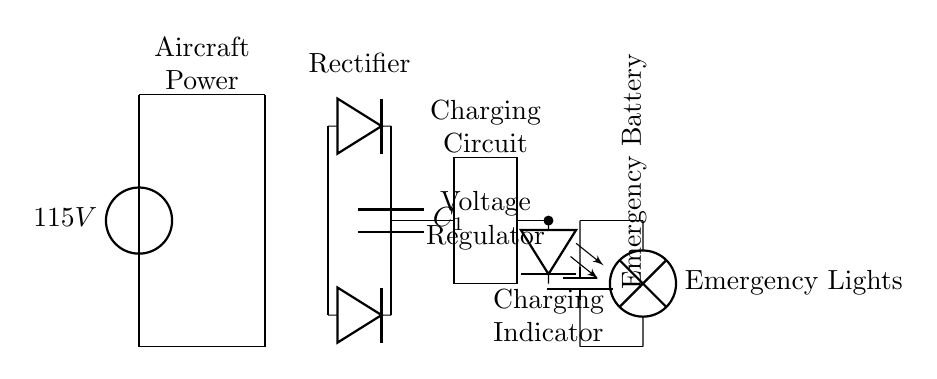What is the primary voltage source for the circuit? The circuit is powered by a primary voltage source of 115V, as indicated by the voltage source symbol at the beginning of the diagram.
Answer: 115V What component is used to convert AC to DC? The circuit includes a rectifier, shown as two diodes connected in such a way to allow current to flow in one direction, effectively converting alternating current from the transformer into direct current for charging.
Answer: Rectifier What type of battery is in this circuit? The circuit contains an emergency battery, which is typically used to power essential systems such as emergency lights during a power failure. This is labeled as "Emergency Battery" in the diagram.
Answer: Emergency Battery What is the purpose of the smoothing capacitor? The capacitor, labeled C1, smooths the output voltage from the rectifier, reducing ripples and providing a more stable DC voltage for charging the battery.
Answer: Smoothing How is the charging indicator represented in the circuit? The charging indicator is represented by a light-emitting diode (LED) symbol, which is connected to the output of the voltage regulator and illuminates when the battery is charging.
Answer: LED Why is a voltage regulator included in this circuit? The voltage regulator ensures that the voltage provided to the emergency battery remains within the required safe charging limits, preventing overcharging and possible damage to the battery.
Answer: Protect battery What do the emergency lights represent in the circuit? The emergency lights are the load in the circuit, connected directly to the battery. When the primary power is lost, the battery provides power to these lights, ensuring safety and visibility.
Answer: Safety lights 